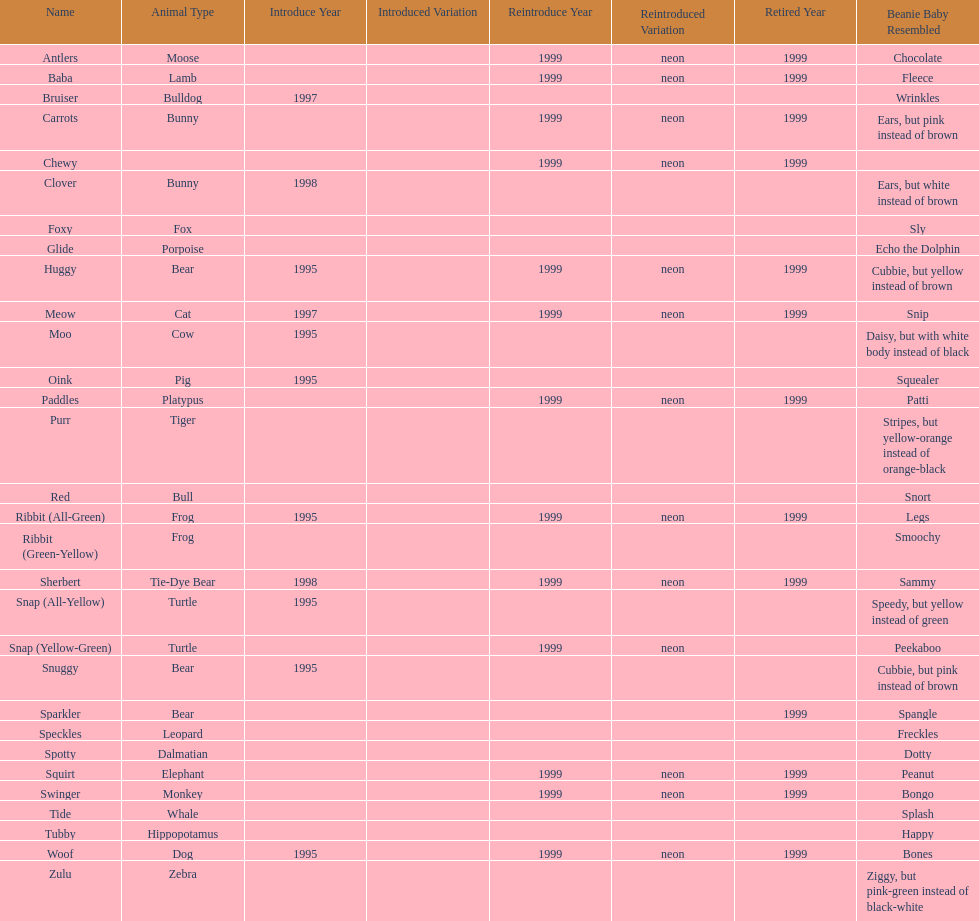Name the only pillow pal that is a dalmatian. Spotty. 